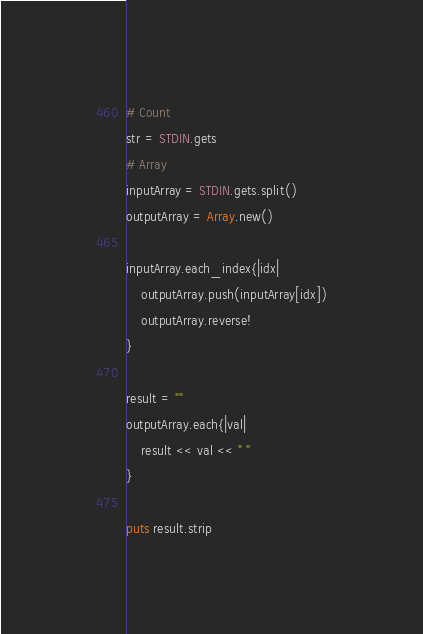Convert code to text. <code><loc_0><loc_0><loc_500><loc_500><_Ruby_># Count
str = STDIN.gets
# Array
inputArray = STDIN.gets.split()
outputArray = Array.new()

inputArray.each_index{|idx|
    outputArray.push(inputArray[idx])
    outputArray.reverse!
}

result = ""
outputArray.each{|val|
    result << val << " "
}

puts result.strip</code> 